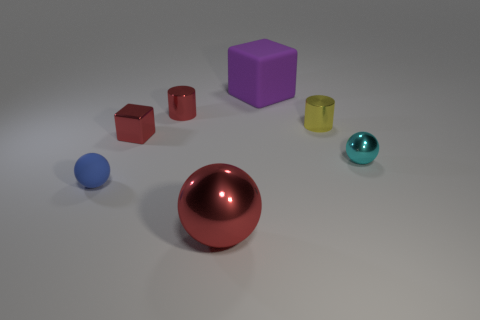There is a small cube that is the same color as the large metal sphere; what is it made of?
Provide a short and direct response. Metal. What number of objects are either small cyan balls or red things that are behind the blue ball?
Your response must be concise. 3. Is the number of small balls that are to the right of the big purple matte block less than the number of blocks?
Give a very brief answer. Yes. There is a red thing that is in front of the small cyan ball right of the tiny ball that is in front of the small cyan thing; what size is it?
Give a very brief answer. Large. There is a object that is both to the right of the tiny blue ball and in front of the cyan shiny thing; what color is it?
Give a very brief answer. Red. What number of cyan objects are there?
Your answer should be compact. 1. Is there anything else that has the same size as the purple rubber thing?
Give a very brief answer. Yes. Do the small red cylinder and the red block have the same material?
Offer a very short reply. Yes. Do the cylinder that is on the left side of the yellow cylinder and the cube that is on the left side of the large purple matte block have the same size?
Ensure brevity in your answer.  Yes. Are there fewer small purple spheres than purple things?
Offer a very short reply. Yes. 